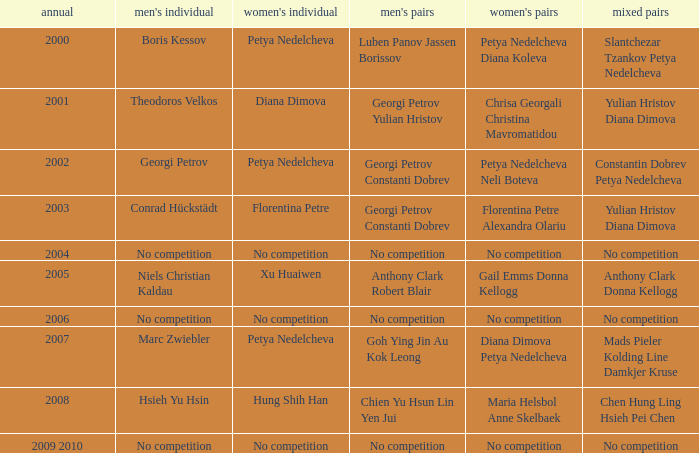What is the year when Conrad Hückstädt won Men's Single? 2003.0. 